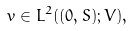Convert formula to latex. <formula><loc_0><loc_0><loc_500><loc_500>v \in L ^ { 2 } ( ( 0 , S ) ; V ) ,</formula> 